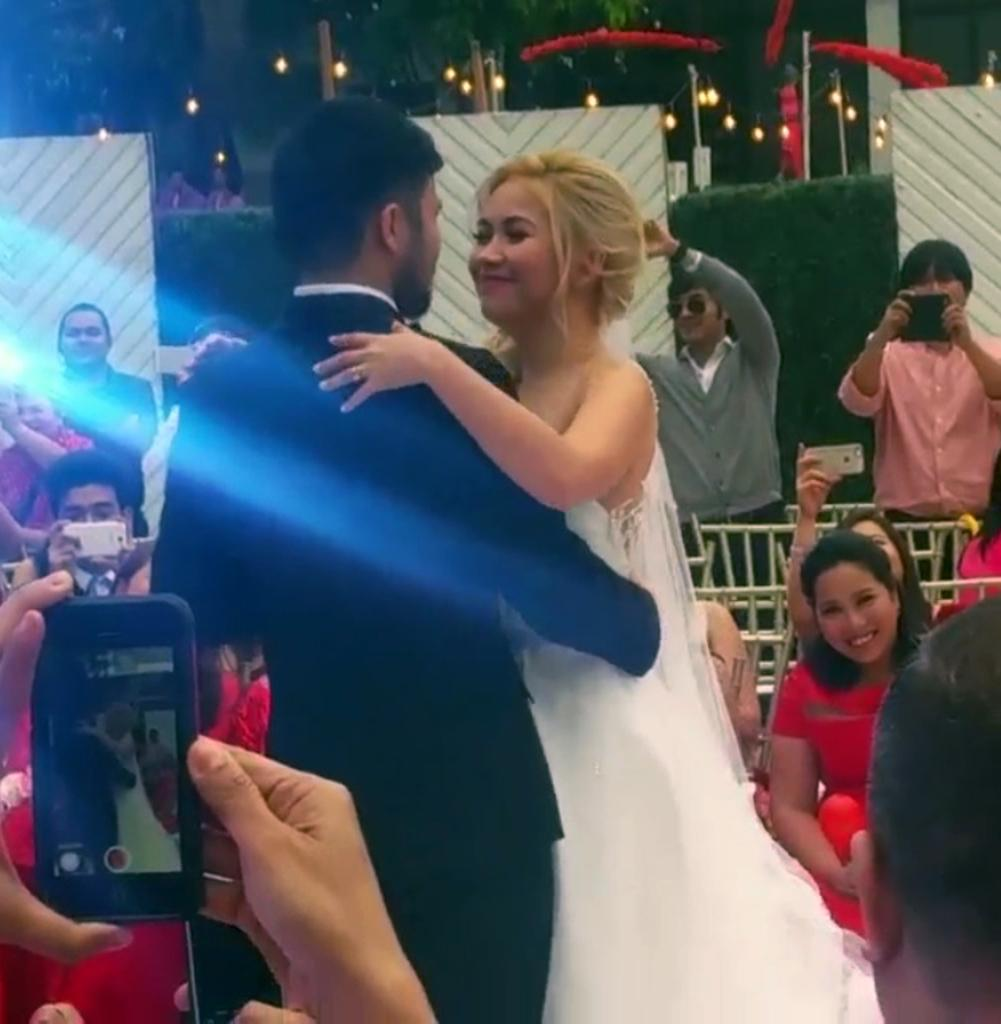How many people are in the image? There is a group of people in the image, but the exact number is not specified. What are the people in the image doing? Some people are seated, while others are standing. What objects are some people holding in the image? Some people are holding mobile phones. What can be seen in the background of the image? There are lights, poles, and trees in the background of the image. Can you see any cactus in the image? There is no mention of a cactus in the image. 